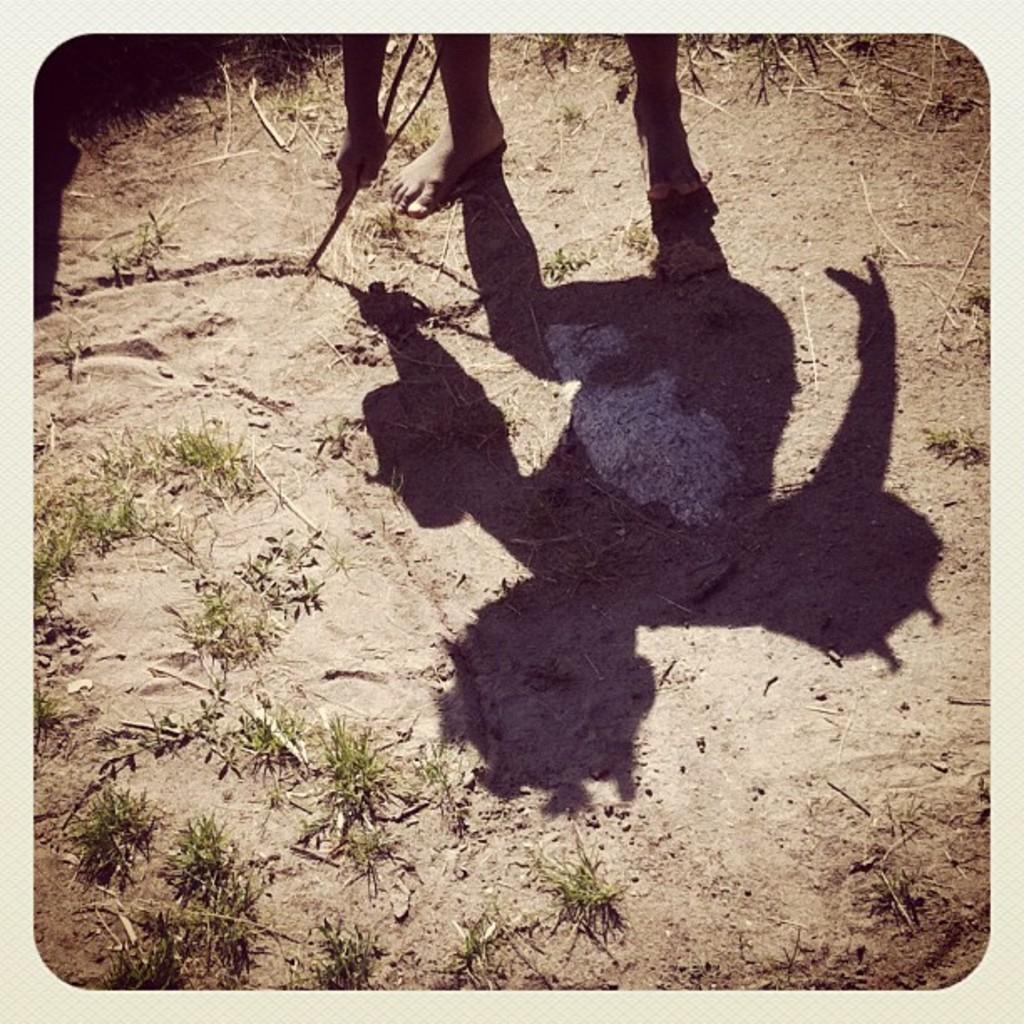How would you summarize this image in a sentence or two? In this picture we can see a person holding a stick. In front of this person we can see plants and shadow of this person on the ground. 